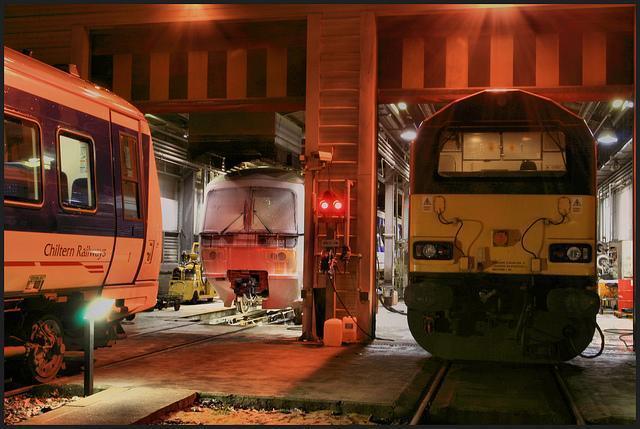How many trains are there?
Give a very brief answer. 3. How many trains are in the photo?
Give a very brief answer. 3. 